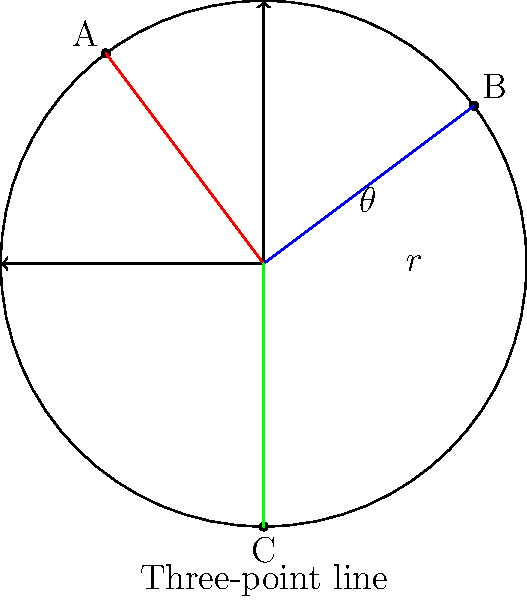In a basketball court analysis using polar coordinates, three shooting positions A, B, and C are marked on the three-point line. If the origin represents the center of the basket, which position has the largest angle $\theta$ from the positive x-axis? To determine which position has the largest angle $\theta$ from the positive x-axis, we need to understand how angles are measured in polar coordinates:

1. Angles are measured counterclockwise from the positive x-axis.
2. The positive x-axis is at 0°, and angles increase counterclockwise.

Let's analyze each position:

A (red line): This point is in the second quadrant. Its angle is between 90° and 180°.

B (blue line): This point is in the first quadrant. Its angle is between 0° and 90°.

C (green line): This point is on the negative y-axis. Its angle is 270° or -90°.

Comparing these angles:
- A has the largest positive angle.
- B has a smaller positive angle than A.
- C has a negative angle, which is actually the largest when considering a full 360° rotation, but in terms of the smallest rotation from the positive x-axis, it's the smallest.

Therefore, position A has the largest angle $\theta$ from the positive x-axis when considering the shortest rotation.
Answer: A 